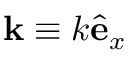<formula> <loc_0><loc_0><loc_500><loc_500>k \equiv k \hat { \mathbf e } _ { x }</formula> 